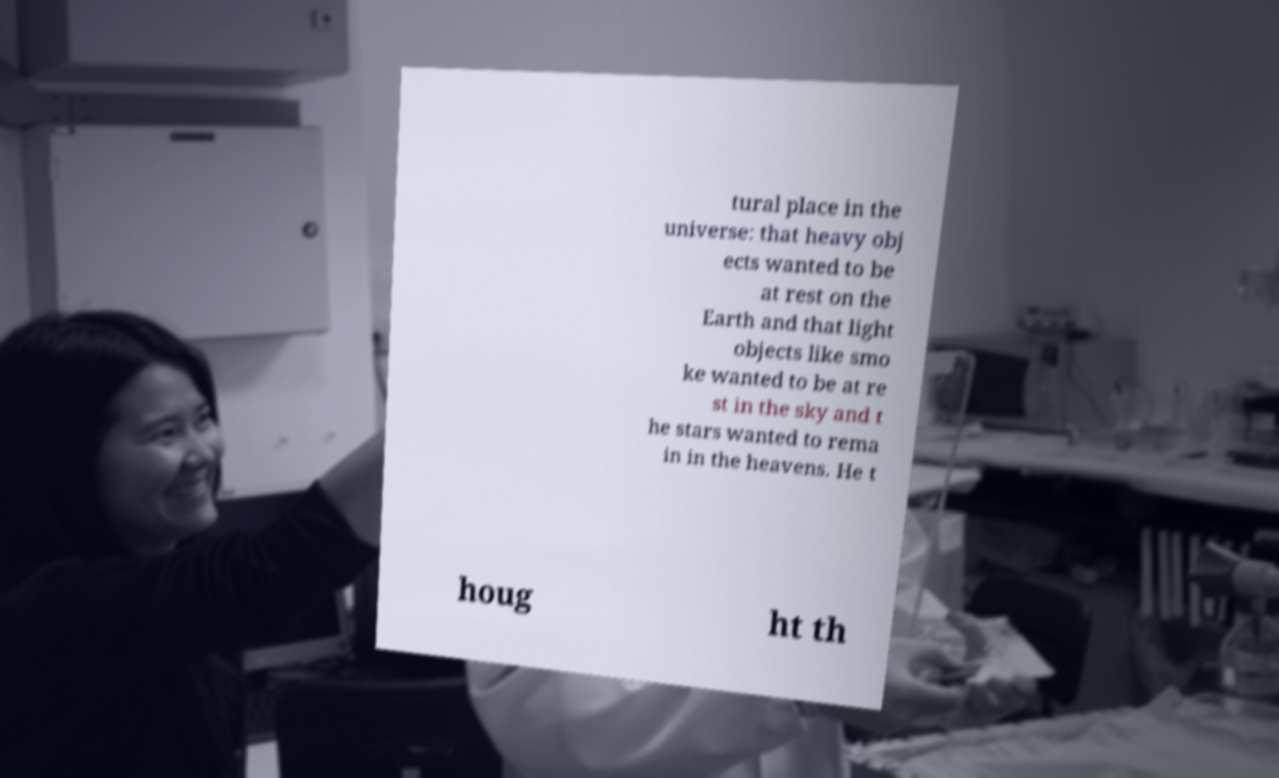Please identify and transcribe the text found in this image. tural place in the universe: that heavy obj ects wanted to be at rest on the Earth and that light objects like smo ke wanted to be at re st in the sky and t he stars wanted to rema in in the heavens. He t houg ht th 